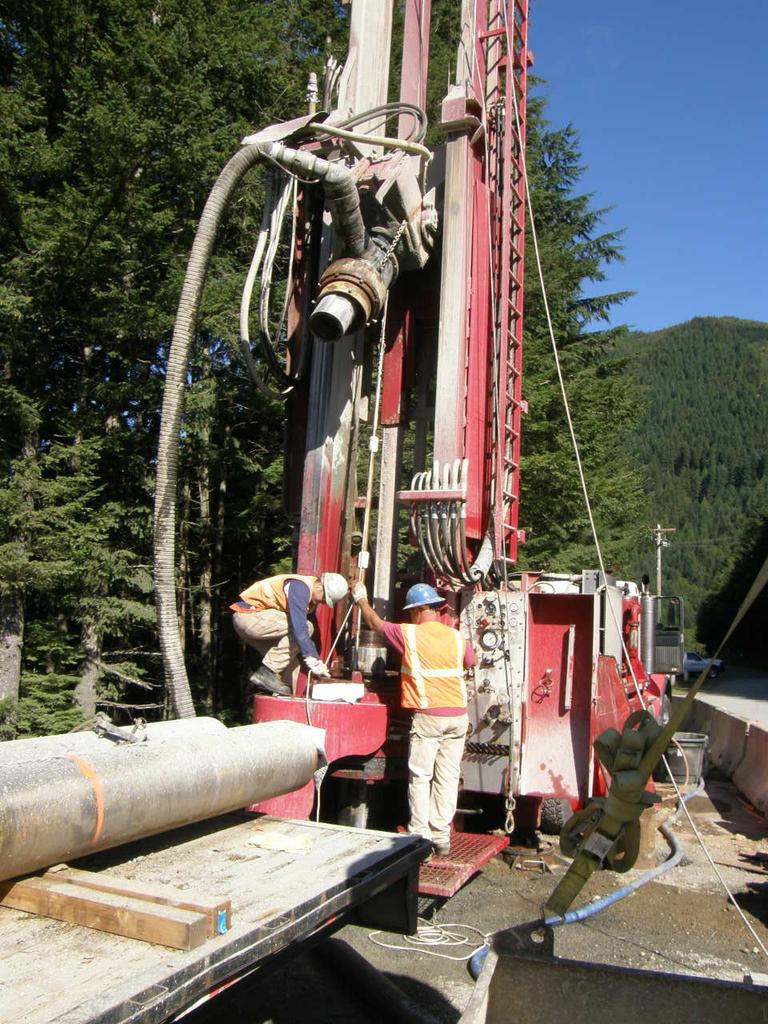What is the main subject of the image? The main subject of the image is a well driller. Are there any other people in the image besides the well driller? Yes, there are people in the image. What can be seen in the background of the image? There are trees and sky visible in the background of the image. What is located on the left side of the image? There are rods on the left side of the image. How does the well driller adjust the distribution of spring water in the image? There is no mention of spring water or any adjustment in the image. 